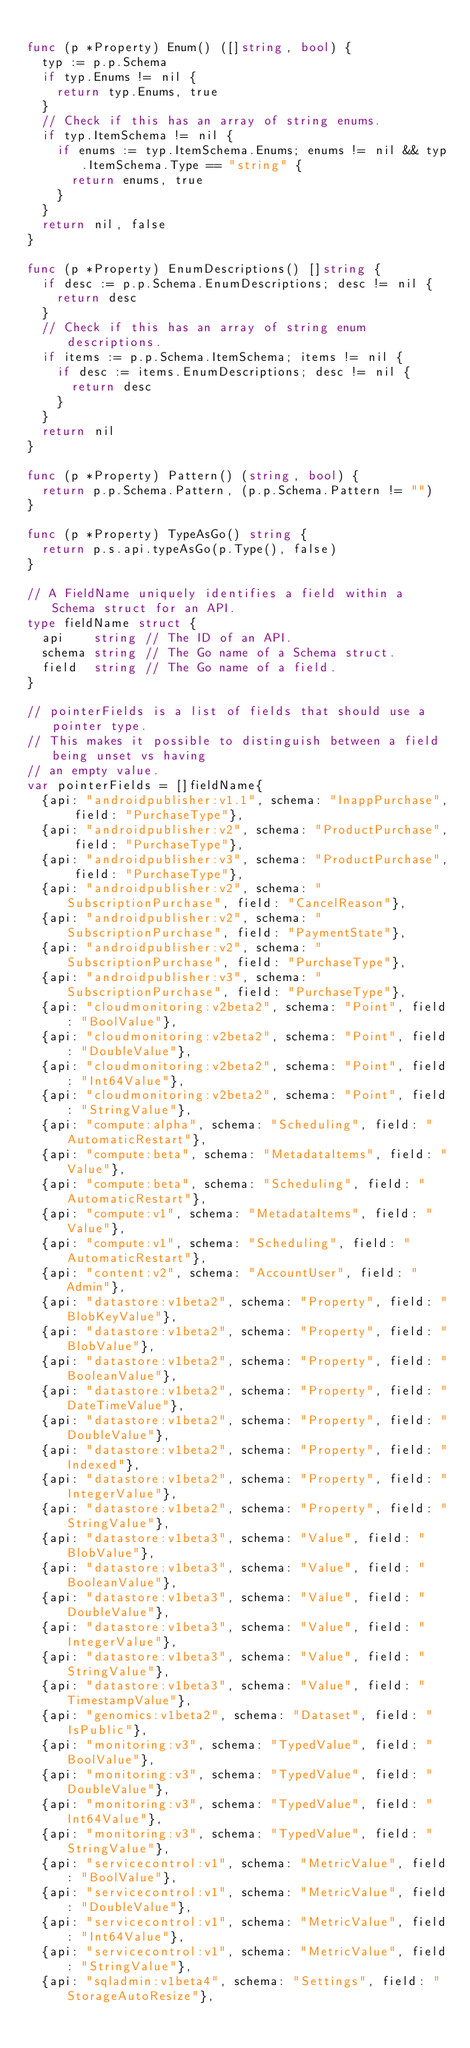Convert code to text. <code><loc_0><loc_0><loc_500><loc_500><_Go_>
func (p *Property) Enum() ([]string, bool) {
	typ := p.p.Schema
	if typ.Enums != nil {
		return typ.Enums, true
	}
	// Check if this has an array of string enums.
	if typ.ItemSchema != nil {
		if enums := typ.ItemSchema.Enums; enums != nil && typ.ItemSchema.Type == "string" {
			return enums, true
		}
	}
	return nil, false
}

func (p *Property) EnumDescriptions() []string {
	if desc := p.p.Schema.EnumDescriptions; desc != nil {
		return desc
	}
	// Check if this has an array of string enum descriptions.
	if items := p.p.Schema.ItemSchema; items != nil {
		if desc := items.EnumDescriptions; desc != nil {
			return desc
		}
	}
	return nil
}

func (p *Property) Pattern() (string, bool) {
	return p.p.Schema.Pattern, (p.p.Schema.Pattern != "")
}

func (p *Property) TypeAsGo() string {
	return p.s.api.typeAsGo(p.Type(), false)
}

// A FieldName uniquely identifies a field within a Schema struct for an API.
type fieldName struct {
	api    string // The ID of an API.
	schema string // The Go name of a Schema struct.
	field  string // The Go name of a field.
}

// pointerFields is a list of fields that should use a pointer type.
// This makes it possible to distinguish between a field being unset vs having
// an empty value.
var pointerFields = []fieldName{
	{api: "androidpublisher:v1.1", schema: "InappPurchase", field: "PurchaseType"},
	{api: "androidpublisher:v2", schema: "ProductPurchase", field: "PurchaseType"},
	{api: "androidpublisher:v3", schema: "ProductPurchase", field: "PurchaseType"},
	{api: "androidpublisher:v2", schema: "SubscriptionPurchase", field: "CancelReason"},
	{api: "androidpublisher:v2", schema: "SubscriptionPurchase", field: "PaymentState"},
	{api: "androidpublisher:v2", schema: "SubscriptionPurchase", field: "PurchaseType"},
	{api: "androidpublisher:v3", schema: "SubscriptionPurchase", field: "PurchaseType"},
	{api: "cloudmonitoring:v2beta2", schema: "Point", field: "BoolValue"},
	{api: "cloudmonitoring:v2beta2", schema: "Point", field: "DoubleValue"},
	{api: "cloudmonitoring:v2beta2", schema: "Point", field: "Int64Value"},
	{api: "cloudmonitoring:v2beta2", schema: "Point", field: "StringValue"},
	{api: "compute:alpha", schema: "Scheduling", field: "AutomaticRestart"},
	{api: "compute:beta", schema: "MetadataItems", field: "Value"},
	{api: "compute:beta", schema: "Scheduling", field: "AutomaticRestart"},
	{api: "compute:v1", schema: "MetadataItems", field: "Value"},
	{api: "compute:v1", schema: "Scheduling", field: "AutomaticRestart"},
	{api: "content:v2", schema: "AccountUser", field: "Admin"},
	{api: "datastore:v1beta2", schema: "Property", field: "BlobKeyValue"},
	{api: "datastore:v1beta2", schema: "Property", field: "BlobValue"},
	{api: "datastore:v1beta2", schema: "Property", field: "BooleanValue"},
	{api: "datastore:v1beta2", schema: "Property", field: "DateTimeValue"},
	{api: "datastore:v1beta2", schema: "Property", field: "DoubleValue"},
	{api: "datastore:v1beta2", schema: "Property", field: "Indexed"},
	{api: "datastore:v1beta2", schema: "Property", field: "IntegerValue"},
	{api: "datastore:v1beta2", schema: "Property", field: "StringValue"},
	{api: "datastore:v1beta3", schema: "Value", field: "BlobValue"},
	{api: "datastore:v1beta3", schema: "Value", field: "BooleanValue"},
	{api: "datastore:v1beta3", schema: "Value", field: "DoubleValue"},
	{api: "datastore:v1beta3", schema: "Value", field: "IntegerValue"},
	{api: "datastore:v1beta3", schema: "Value", field: "StringValue"},
	{api: "datastore:v1beta3", schema: "Value", field: "TimestampValue"},
	{api: "genomics:v1beta2", schema: "Dataset", field: "IsPublic"},
	{api: "monitoring:v3", schema: "TypedValue", field: "BoolValue"},
	{api: "monitoring:v3", schema: "TypedValue", field: "DoubleValue"},
	{api: "monitoring:v3", schema: "TypedValue", field: "Int64Value"},
	{api: "monitoring:v3", schema: "TypedValue", field: "StringValue"},
	{api: "servicecontrol:v1", schema: "MetricValue", field: "BoolValue"},
	{api: "servicecontrol:v1", schema: "MetricValue", field: "DoubleValue"},
	{api: "servicecontrol:v1", schema: "MetricValue", field: "Int64Value"},
	{api: "servicecontrol:v1", schema: "MetricValue", field: "StringValue"},
	{api: "sqladmin:v1beta4", schema: "Settings", field: "StorageAutoResize"},</code> 